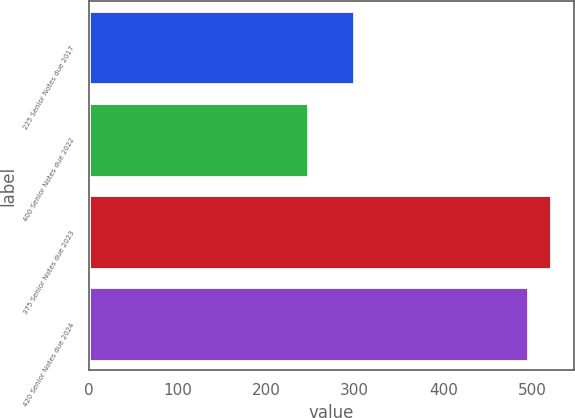Convert chart. <chart><loc_0><loc_0><loc_500><loc_500><bar_chart><fcel>225 Senior Notes due 2017<fcel>400 Senior Notes due 2022<fcel>375 Senior Notes due 2023<fcel>420 Senior Notes due 2024<nl><fcel>299.4<fcel>247<fcel>521.16<fcel>496.2<nl></chart> 